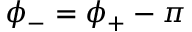<formula> <loc_0><loc_0><loc_500><loc_500>\phi _ { - } = \phi _ { + } - \pi</formula> 